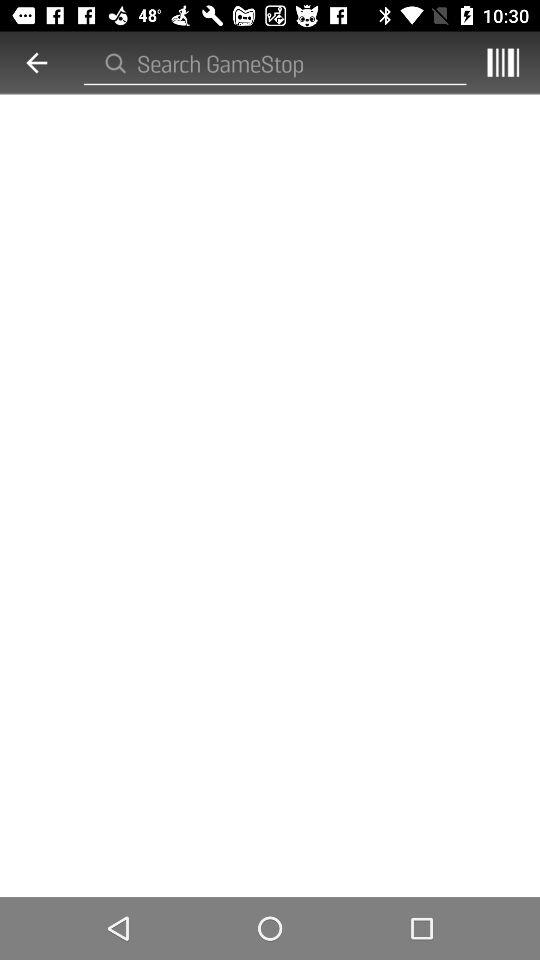What is to be searched for in the search bar? In the search bar, search for "GameStop". 